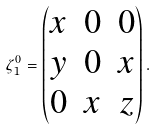<formula> <loc_0><loc_0><loc_500><loc_500>\zeta _ { 1 } ^ { 0 } = \begin{pmatrix} x & 0 & 0 \\ y & 0 & x \\ 0 & x & z \end{pmatrix} .</formula> 